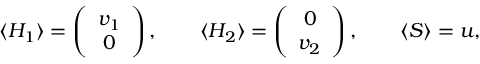Convert formula to latex. <formula><loc_0><loc_0><loc_500><loc_500>\langle H _ { 1 } \rangle = \left ( \begin{array} { c } { { v _ { 1 } } } \\ { 0 } \end{array} \right ) , \quad \langle H _ { 2 } \rangle = \left ( \begin{array} { c } { 0 } \\ { { v _ { 2 } } } \end{array} \right ) , \quad \langle S \rangle = u ,</formula> 